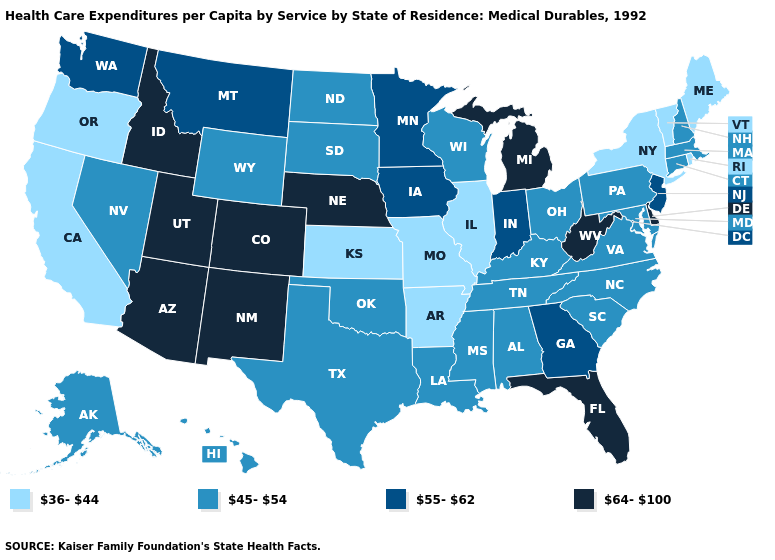Which states hav the highest value in the South?
Quick response, please. Delaware, Florida, West Virginia. Does the map have missing data?
Give a very brief answer. No. What is the value of Oklahoma?
Short answer required. 45-54. What is the value of Arkansas?
Quick response, please. 36-44. What is the value of North Dakota?
Concise answer only. 45-54. Does the map have missing data?
Short answer required. No. Does Pennsylvania have a higher value than Idaho?
Give a very brief answer. No. What is the value of Virginia?
Write a very short answer. 45-54. Name the states that have a value in the range 64-100?
Short answer required. Arizona, Colorado, Delaware, Florida, Idaho, Michigan, Nebraska, New Mexico, Utah, West Virginia. Name the states that have a value in the range 64-100?
Short answer required. Arizona, Colorado, Delaware, Florida, Idaho, Michigan, Nebraska, New Mexico, Utah, West Virginia. Does New Mexico have a lower value than Oklahoma?
Be succinct. No. Name the states that have a value in the range 45-54?
Write a very short answer. Alabama, Alaska, Connecticut, Hawaii, Kentucky, Louisiana, Maryland, Massachusetts, Mississippi, Nevada, New Hampshire, North Carolina, North Dakota, Ohio, Oklahoma, Pennsylvania, South Carolina, South Dakota, Tennessee, Texas, Virginia, Wisconsin, Wyoming. Which states have the lowest value in the USA?
Give a very brief answer. Arkansas, California, Illinois, Kansas, Maine, Missouri, New York, Oregon, Rhode Island, Vermont. What is the value of Alabama?
Concise answer only. 45-54. What is the value of South Carolina?
Be succinct. 45-54. 